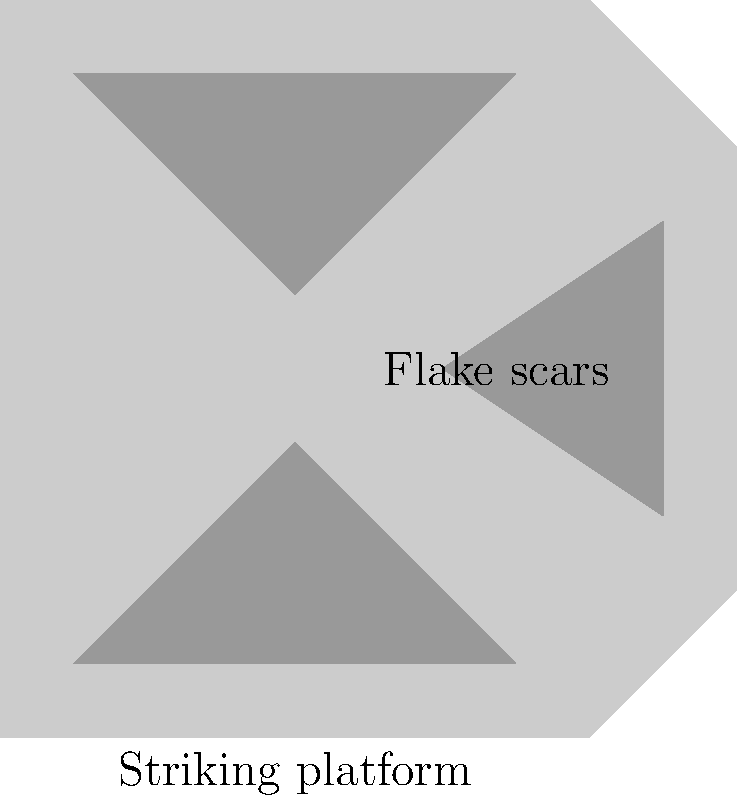As a reporter covering archaeological discoveries, you've encountered a close-up image of a stone artifact. Which tool-making technique is most likely represented by the pattern of flake scars and the presence of a striking platform in this image? To determine the tool-making technique, let's analyze the image step-by-step:

1. Observe the overall shape: The artifact has a roughly rectangular shape with a flat bottom (striking platform) and angled sides.

2. Identify the flake scars: There are multiple concave depressions on the surface of the artifact, indicating where flakes have been removed.

3. Note the striking platform: The flat bottom of the artifact serves as a striking platform, which is a key feature in certain knapping techniques.

4. Consider the pattern of flake scars: The scars appear to be removed from multiple directions, creating a controlled, systematic pattern.

5. Analyze the technique: The combination of a striking platform and systematic flake removal suggests a controlled knapping process.

6. Identify the specific technique: This pattern is characteristic of the Levallois technique, a sophisticated stone tool production method developed during the Middle Paleolithic period.

7. Understand the Levallois technique: It involves preparing a core to predetermine the shape of the flake that will be struck from it, allowing for more efficient use of raw materials and production of standardized tools.

Given these observations, the tool-making technique most likely represented in this image is the Levallois technique, a advanced method of stone tool production that demonstrates the cognitive abilities of early humans.
Answer: Levallois technique 